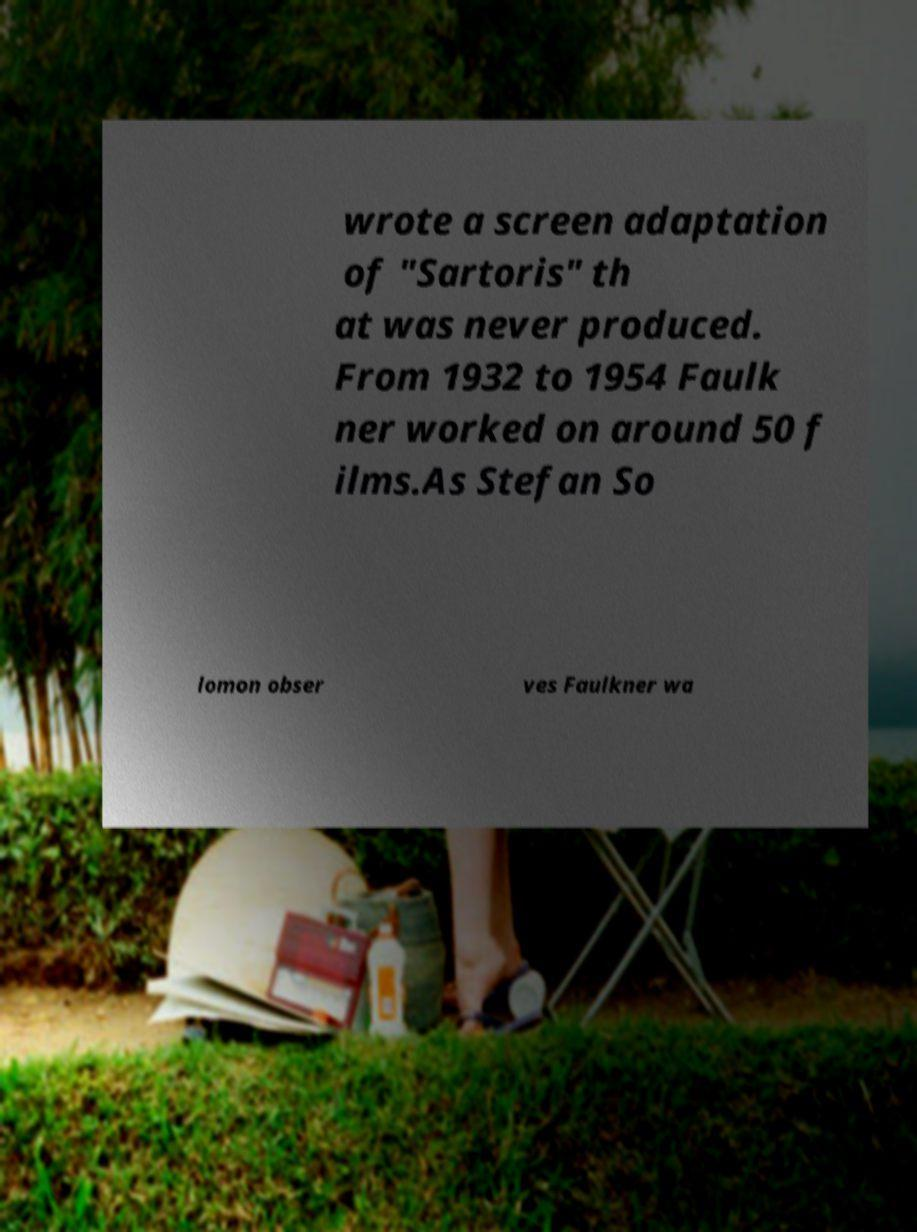Could you assist in decoding the text presented in this image and type it out clearly? wrote a screen adaptation of "Sartoris" th at was never produced. From 1932 to 1954 Faulk ner worked on around 50 f ilms.As Stefan So lomon obser ves Faulkner wa 